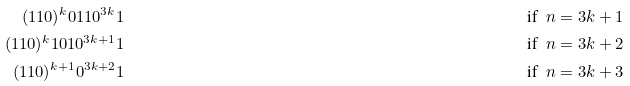Convert formula to latex. <formula><loc_0><loc_0><loc_500><loc_500>( 1 1 0 ) ^ { k } 0 1 1 0 ^ { 3 k } 1 & & \text {if\ \ $n = 3 k + 1$} \\ ( 1 1 0 ) ^ { k } 1 0 1 0 ^ { 3 k + 1 } 1 & & \text {if\ \ $n = 3 k + 2$} \\ ( 1 1 0 ) ^ { k + 1 } 0 ^ { 3 k + 2 } 1 & & \text {if\ \ $n = 3 k + 3$}</formula> 